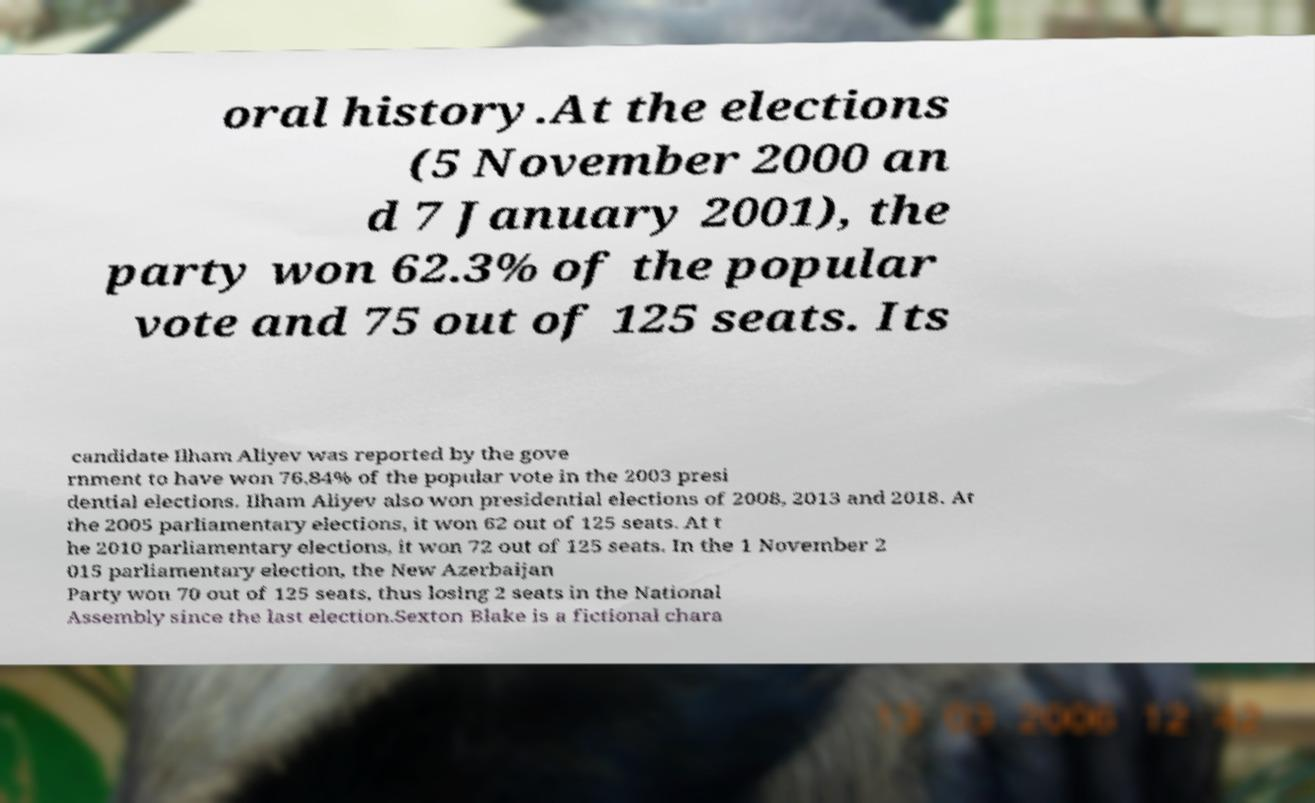I need the written content from this picture converted into text. Can you do that? oral history.At the elections (5 November 2000 an d 7 January 2001), the party won 62.3% of the popular vote and 75 out of 125 seats. Its candidate Ilham Aliyev was reported by the gove rnment to have won 76,84% of the popular vote in the 2003 presi dential elections. Ilham Aliyev also won presidential elections of 2008, 2013 and 2018. At the 2005 parliamentary elections, it won 62 out of 125 seats. At t he 2010 parliamentary elections, it won 72 out of 125 seats. In the 1 November 2 015 parliamentary election, the New Azerbaijan Party won 70 out of 125 seats, thus losing 2 seats in the National Assembly since the last election.Sexton Blake is a fictional chara 